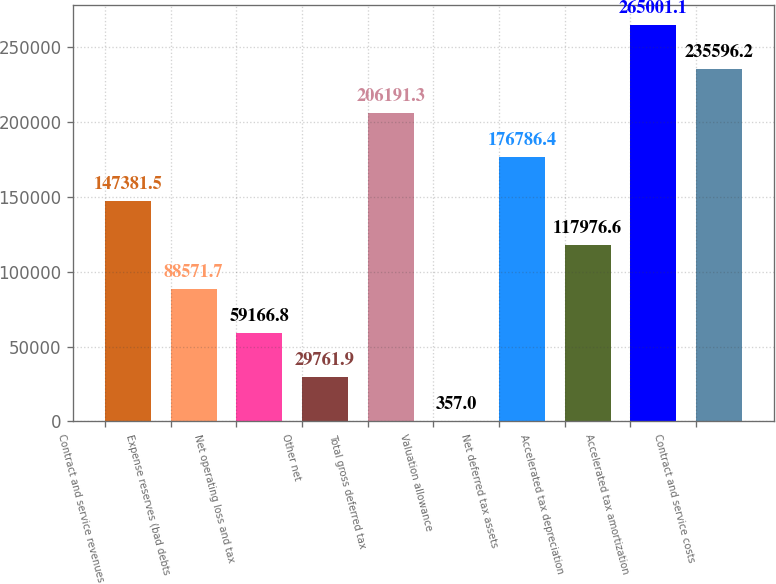Convert chart to OTSL. <chart><loc_0><loc_0><loc_500><loc_500><bar_chart><fcel>Contract and service revenues<fcel>Expense reserves (bad debts<fcel>Net operating loss and tax<fcel>Other net<fcel>Total gross deferred tax<fcel>Valuation allowance<fcel>Net deferred tax assets<fcel>Accelerated tax depreciation<fcel>Accelerated tax amortization<fcel>Contract and service costs<nl><fcel>147382<fcel>88571.7<fcel>59166.8<fcel>29761.9<fcel>206191<fcel>357<fcel>176786<fcel>117977<fcel>265001<fcel>235596<nl></chart> 